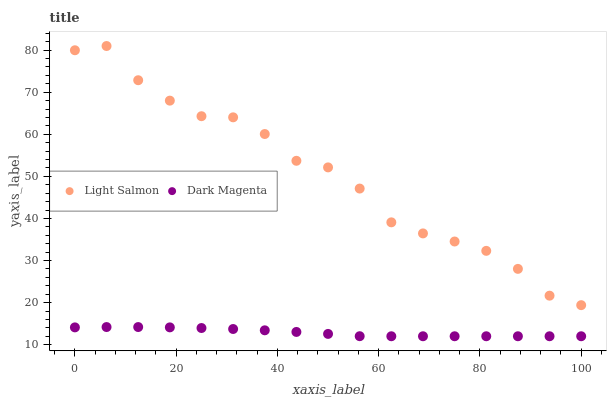Does Dark Magenta have the minimum area under the curve?
Answer yes or no. Yes. Does Light Salmon have the maximum area under the curve?
Answer yes or no. Yes. Does Dark Magenta have the maximum area under the curve?
Answer yes or no. No. Is Dark Magenta the smoothest?
Answer yes or no. Yes. Is Light Salmon the roughest?
Answer yes or no. Yes. Is Dark Magenta the roughest?
Answer yes or no. No. Does Dark Magenta have the lowest value?
Answer yes or no. Yes. Does Light Salmon have the highest value?
Answer yes or no. Yes. Does Dark Magenta have the highest value?
Answer yes or no. No. Is Dark Magenta less than Light Salmon?
Answer yes or no. Yes. Is Light Salmon greater than Dark Magenta?
Answer yes or no. Yes. Does Dark Magenta intersect Light Salmon?
Answer yes or no. No. 